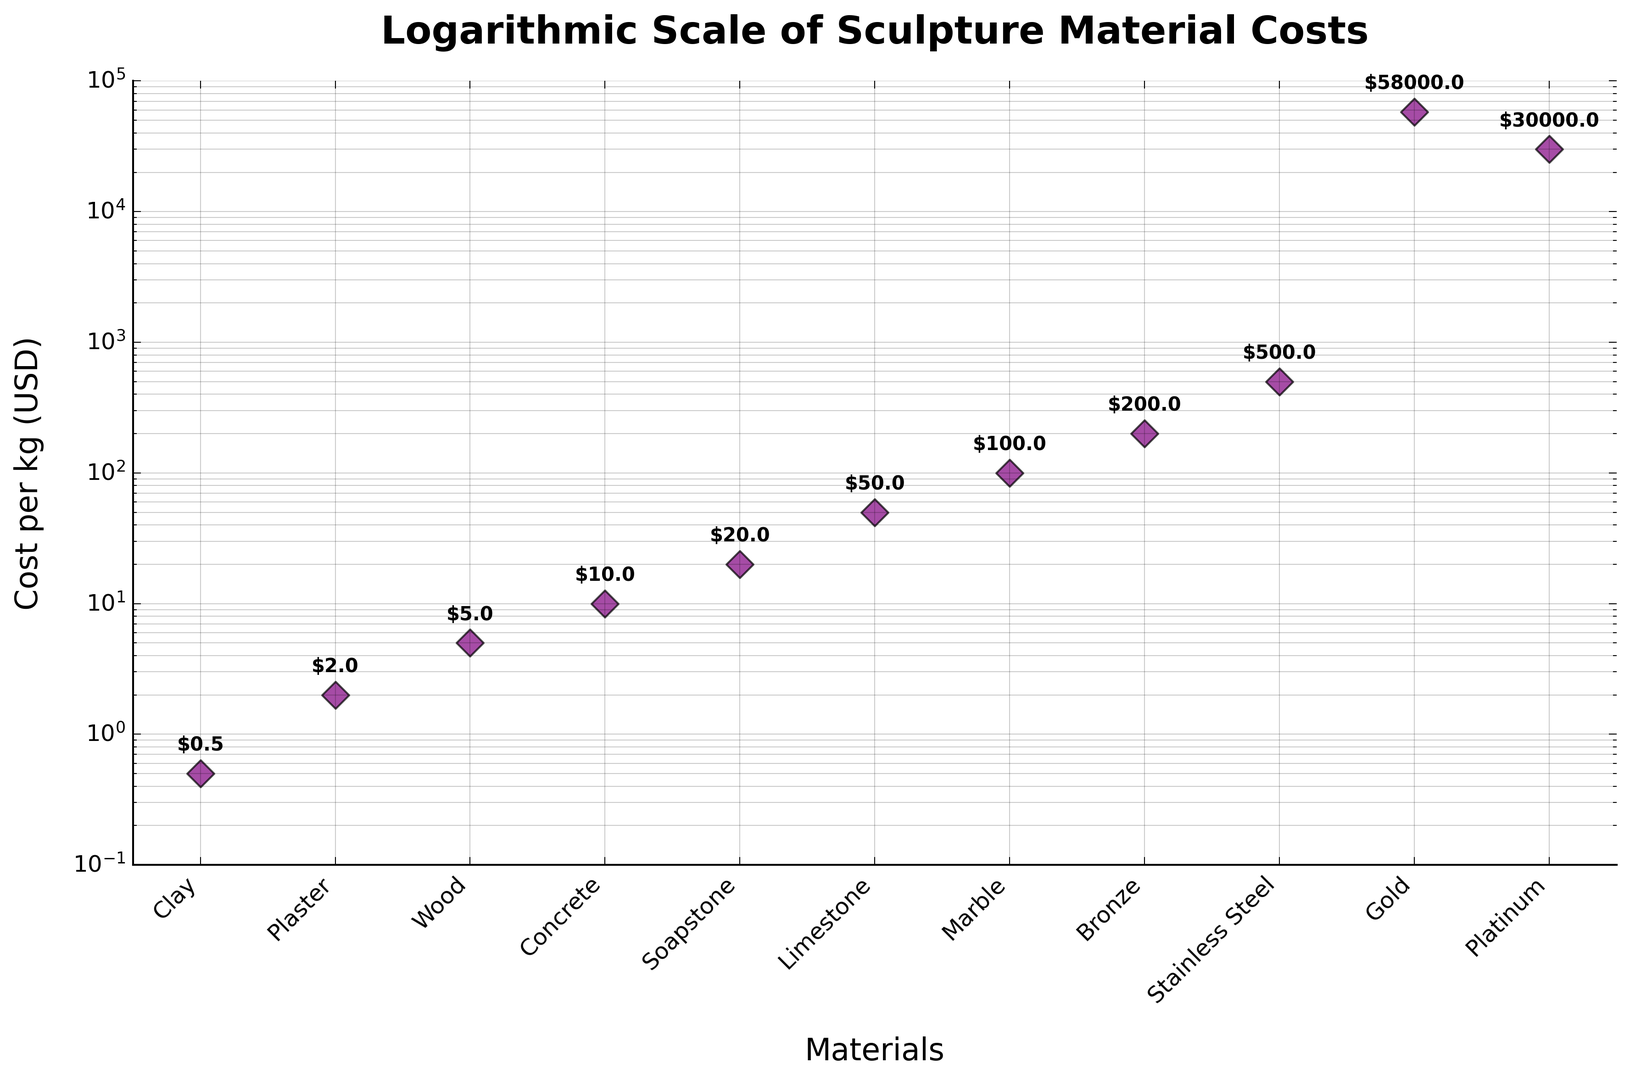what is the least expensive material for sculpture based on the graph? The least expensive material is visually identified at the lowest point on the y-axis of the scatter plot. Referring to the figure, Clay is at the bottom with a cost of $0.5 per kg.
Answer: Clay Which material is more expensive, Marble or Bronze? By comparing their positions on the y-axis, Bronze is situated higher than Marble, indicating that Bronze is more expensive. Bronze costs $200 per kg, while Marble costs $100 per kg.
Answer: Bronze What is the cost difference between Stainless Steel and Gold? The cost of Stainless Steel is $500 per kg and Gold is $58000 per kg. Subtract the cost of Stainless Steel from the cost of Gold: $58000 - $500 = $57500.
Answer: $57500 If you were to buy 1 kg each of Wood and Soapstone, how much would it cost in total? Adding the costs of Wood and Soapstone based on their values on the plot, $5 + $20 = $25.
Answer: $25 On average, how much do Concrete and Platinum cost per kg? Find the mean of the costs of Concrete and Platinum as shown on the chart. Sum the costs: $10 + $30000 = $30010. Then divide by 2: $30010 / 2 = $15005.
Answer: $15005 What is the median cost of all the materials displayed on the plot? List the costs from lowest to highest: 0.5, 2, 5, 10, 20, 50, 100, 200, 500, 30000, 58000. The middle value (6th element) in this ordered list is 50.
Answer: $50 Which materials have a cost per kg between $10 and $200? Identify the materials within the y-axis range from $10 to $200 on the plot: Concrete ($10), Soapstone ($20), Limestone ($50), Marble ($100), Bronze ($200).
Answer: Concrete, Soapstone, Limestone, Marble, Bronze How many materials have a cost per kg greater than $100? By observing the chart, the materials situated above the $100 mark include Bronze ($200), Stainless Steel ($500), Platinum ($30000), and Gold ($58000). Counting these items gives 4 materials.
Answer: 4 materials What is the ratio of the cost per kg of Stainless Steel to the cost per kg of Clay? By observing their values, Stainless Steel costs $500 per kg and Clay costs $0.5 per kg. The ratio is calculated as $500 / $0.5 = 1000.
Answer: 1000 